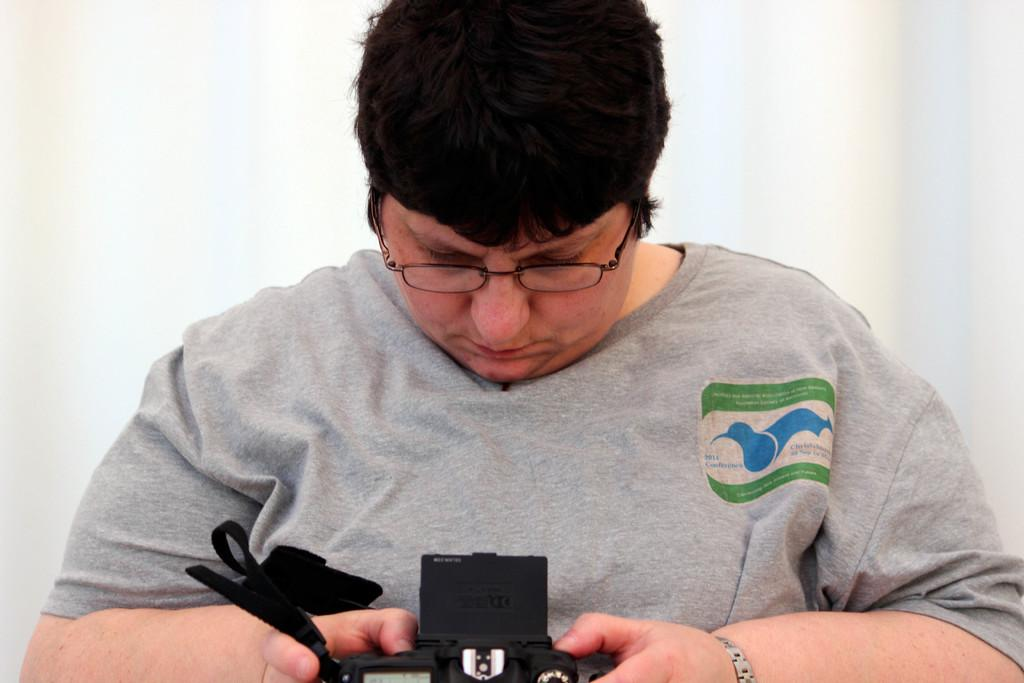What is the main subject of the image? The main subject of the image is a man. What is the man wearing in the image? The man is wearing a gray t-shirt in the image. Are there any accessories visible on the man? Yes, the man is wearing spectacles in the image. What is the man doing in the image? The man is looking towards a camera in the image. What type of journey is the man embarking on in the image? There is no indication of a journey in the image; it simply shows a man looking towards a camera. What is the connection between the man and the camera in the image? The connection between the man and the camera in the image is that the man is looking towards the camera, but there is no further information about their relationship or purpose. 